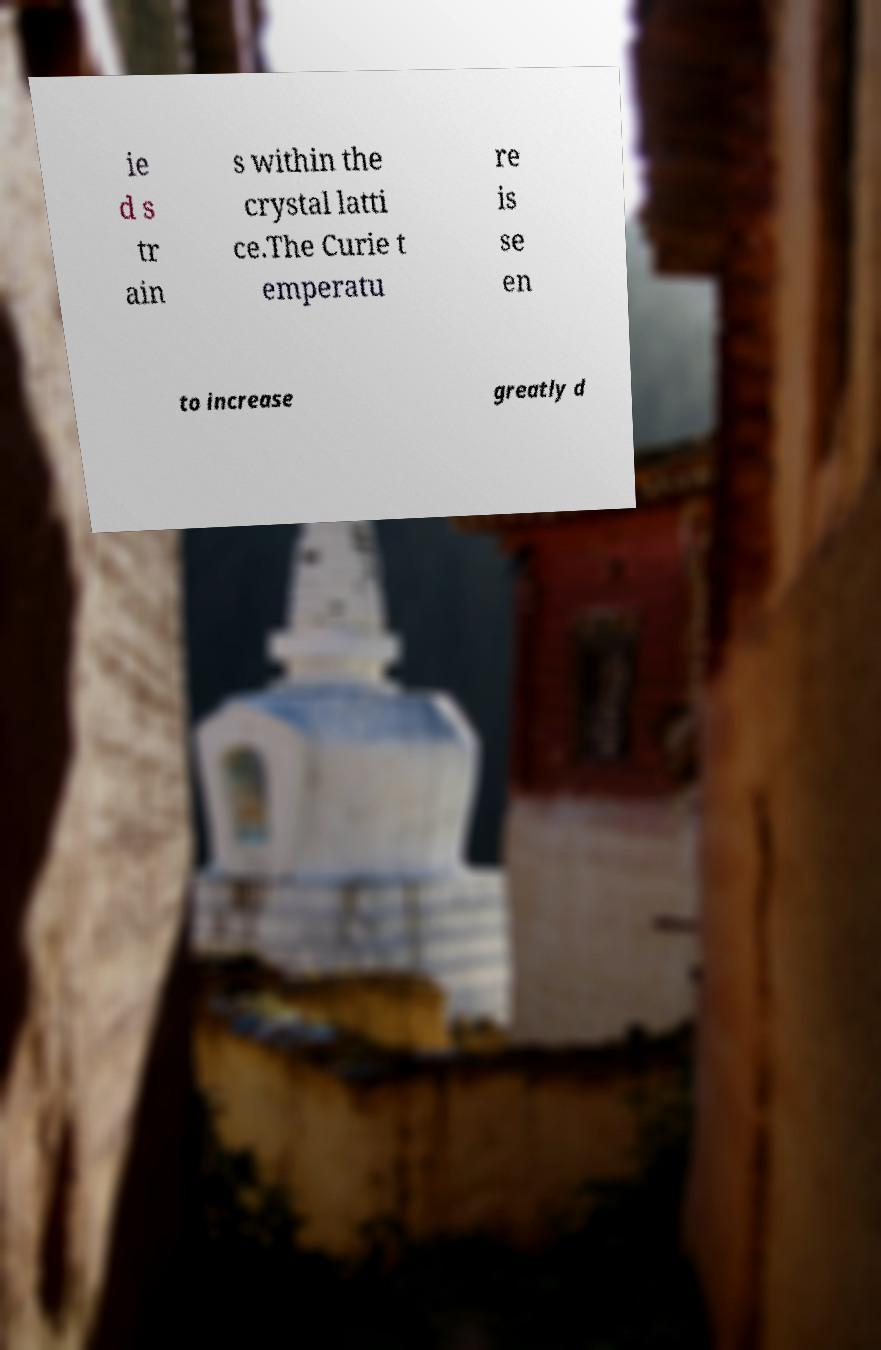Can you read and provide the text displayed in the image?This photo seems to have some interesting text. Can you extract and type it out for me? ie d s tr ain s within the crystal latti ce.The Curie t emperatu re is se en to increase greatly d 